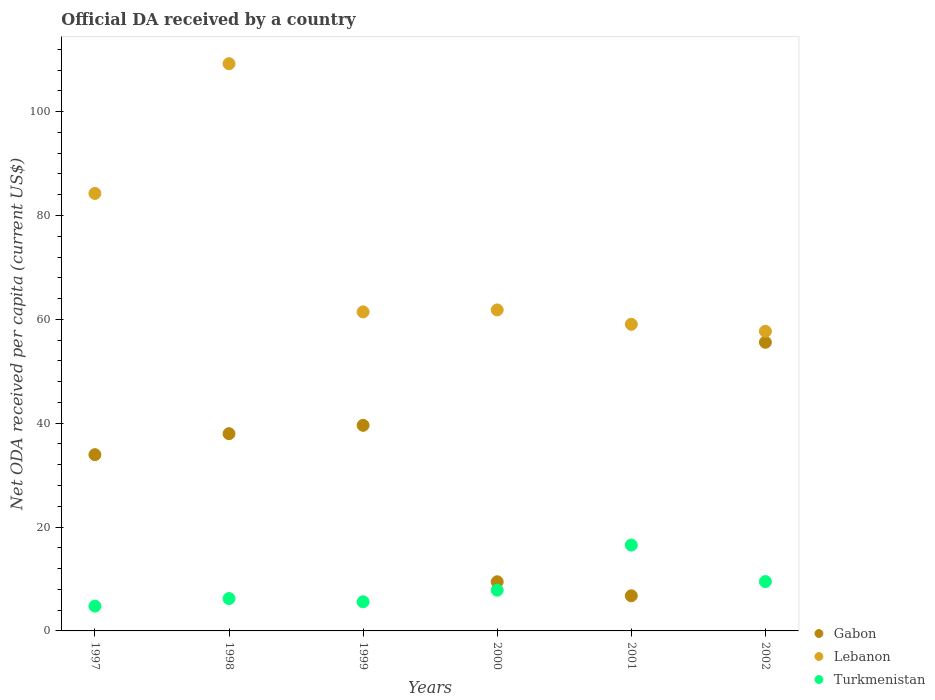Is the number of dotlines equal to the number of legend labels?
Provide a short and direct response. Yes. What is the ODA received in in Lebanon in 2000?
Offer a very short reply. 61.82. Across all years, what is the maximum ODA received in in Lebanon?
Your response must be concise. 109.24. Across all years, what is the minimum ODA received in in Gabon?
Your answer should be compact. 6.77. In which year was the ODA received in in Lebanon maximum?
Your answer should be compact. 1998. In which year was the ODA received in in Gabon minimum?
Give a very brief answer. 2001. What is the total ODA received in in Gabon in the graph?
Your answer should be very brief. 183.35. What is the difference between the ODA received in in Gabon in 1999 and that in 2001?
Provide a short and direct response. 32.83. What is the difference between the ODA received in in Lebanon in 1998 and the ODA received in in Turkmenistan in 1997?
Provide a succinct answer. 104.47. What is the average ODA received in in Turkmenistan per year?
Offer a terse response. 8.42. In the year 2000, what is the difference between the ODA received in in Gabon and ODA received in in Turkmenistan?
Offer a terse response. 1.63. In how many years, is the ODA received in in Lebanon greater than 52 US$?
Keep it short and to the point. 6. What is the ratio of the ODA received in in Lebanon in 2000 to that in 2001?
Your response must be concise. 1.05. Is the ODA received in in Lebanon in 1998 less than that in 2002?
Provide a short and direct response. No. Is the difference between the ODA received in in Gabon in 1998 and 2002 greater than the difference between the ODA received in in Turkmenistan in 1998 and 2002?
Your answer should be very brief. No. What is the difference between the highest and the second highest ODA received in in Gabon?
Offer a terse response. 15.99. What is the difference between the highest and the lowest ODA received in in Lebanon?
Your answer should be compact. 51.54. In how many years, is the ODA received in in Lebanon greater than the average ODA received in in Lebanon taken over all years?
Your answer should be compact. 2. How many years are there in the graph?
Provide a succinct answer. 6. What is the difference between two consecutive major ticks on the Y-axis?
Your response must be concise. 20. How many legend labels are there?
Offer a very short reply. 3. What is the title of the graph?
Ensure brevity in your answer.  Official DA received by a country. What is the label or title of the X-axis?
Provide a succinct answer. Years. What is the label or title of the Y-axis?
Your answer should be compact. Net ODA received per capita (current US$). What is the Net ODA received per capita (current US$) in Gabon in 1997?
Your response must be concise. 33.95. What is the Net ODA received per capita (current US$) of Lebanon in 1997?
Make the answer very short. 84.26. What is the Net ODA received per capita (current US$) of Turkmenistan in 1997?
Keep it short and to the point. 4.77. What is the Net ODA received per capita (current US$) in Gabon in 1998?
Your answer should be compact. 37.98. What is the Net ODA received per capita (current US$) in Lebanon in 1998?
Make the answer very short. 109.24. What is the Net ODA received per capita (current US$) in Turkmenistan in 1998?
Offer a terse response. 6.24. What is the Net ODA received per capita (current US$) of Gabon in 1999?
Your response must be concise. 39.6. What is the Net ODA received per capita (current US$) in Lebanon in 1999?
Provide a succinct answer. 61.44. What is the Net ODA received per capita (current US$) in Turkmenistan in 1999?
Provide a succinct answer. 5.61. What is the Net ODA received per capita (current US$) of Gabon in 2000?
Make the answer very short. 9.47. What is the Net ODA received per capita (current US$) in Lebanon in 2000?
Give a very brief answer. 61.82. What is the Net ODA received per capita (current US$) of Turkmenistan in 2000?
Ensure brevity in your answer.  7.84. What is the Net ODA received per capita (current US$) in Gabon in 2001?
Ensure brevity in your answer.  6.77. What is the Net ODA received per capita (current US$) in Lebanon in 2001?
Provide a succinct answer. 59.06. What is the Net ODA received per capita (current US$) in Turkmenistan in 2001?
Give a very brief answer. 16.53. What is the Net ODA received per capita (current US$) in Gabon in 2002?
Make the answer very short. 55.59. What is the Net ODA received per capita (current US$) in Lebanon in 2002?
Your response must be concise. 57.7. What is the Net ODA received per capita (current US$) in Turkmenistan in 2002?
Provide a short and direct response. 9.51. Across all years, what is the maximum Net ODA received per capita (current US$) of Gabon?
Ensure brevity in your answer.  55.59. Across all years, what is the maximum Net ODA received per capita (current US$) of Lebanon?
Ensure brevity in your answer.  109.24. Across all years, what is the maximum Net ODA received per capita (current US$) of Turkmenistan?
Your response must be concise. 16.53. Across all years, what is the minimum Net ODA received per capita (current US$) of Gabon?
Give a very brief answer. 6.77. Across all years, what is the minimum Net ODA received per capita (current US$) in Lebanon?
Provide a succinct answer. 57.7. Across all years, what is the minimum Net ODA received per capita (current US$) in Turkmenistan?
Your response must be concise. 4.77. What is the total Net ODA received per capita (current US$) in Gabon in the graph?
Offer a very short reply. 183.35. What is the total Net ODA received per capita (current US$) in Lebanon in the graph?
Offer a terse response. 433.52. What is the total Net ODA received per capita (current US$) in Turkmenistan in the graph?
Your response must be concise. 50.51. What is the difference between the Net ODA received per capita (current US$) in Gabon in 1997 and that in 1998?
Your answer should be compact. -4.04. What is the difference between the Net ODA received per capita (current US$) of Lebanon in 1997 and that in 1998?
Provide a succinct answer. -24.98. What is the difference between the Net ODA received per capita (current US$) in Turkmenistan in 1997 and that in 1998?
Ensure brevity in your answer.  -1.46. What is the difference between the Net ODA received per capita (current US$) in Gabon in 1997 and that in 1999?
Give a very brief answer. -5.65. What is the difference between the Net ODA received per capita (current US$) of Lebanon in 1997 and that in 1999?
Your answer should be compact. 22.82. What is the difference between the Net ODA received per capita (current US$) in Turkmenistan in 1997 and that in 1999?
Provide a succinct answer. -0.84. What is the difference between the Net ODA received per capita (current US$) of Gabon in 1997 and that in 2000?
Ensure brevity in your answer.  24.48. What is the difference between the Net ODA received per capita (current US$) of Lebanon in 1997 and that in 2000?
Your response must be concise. 22.44. What is the difference between the Net ODA received per capita (current US$) of Turkmenistan in 1997 and that in 2000?
Your answer should be compact. -3.07. What is the difference between the Net ODA received per capita (current US$) in Gabon in 1997 and that in 2001?
Offer a very short reply. 27.18. What is the difference between the Net ODA received per capita (current US$) in Lebanon in 1997 and that in 2001?
Make the answer very short. 25.2. What is the difference between the Net ODA received per capita (current US$) of Turkmenistan in 1997 and that in 2001?
Ensure brevity in your answer.  -11.76. What is the difference between the Net ODA received per capita (current US$) in Gabon in 1997 and that in 2002?
Your response must be concise. -21.64. What is the difference between the Net ODA received per capita (current US$) of Lebanon in 1997 and that in 2002?
Ensure brevity in your answer.  26.56. What is the difference between the Net ODA received per capita (current US$) of Turkmenistan in 1997 and that in 2002?
Offer a very short reply. -4.73. What is the difference between the Net ODA received per capita (current US$) of Gabon in 1998 and that in 1999?
Your answer should be compact. -1.61. What is the difference between the Net ODA received per capita (current US$) of Lebanon in 1998 and that in 1999?
Offer a terse response. 47.8. What is the difference between the Net ODA received per capita (current US$) of Turkmenistan in 1998 and that in 1999?
Offer a very short reply. 0.62. What is the difference between the Net ODA received per capita (current US$) of Gabon in 1998 and that in 2000?
Make the answer very short. 28.52. What is the difference between the Net ODA received per capita (current US$) of Lebanon in 1998 and that in 2000?
Ensure brevity in your answer.  47.42. What is the difference between the Net ODA received per capita (current US$) in Turkmenistan in 1998 and that in 2000?
Offer a terse response. -1.61. What is the difference between the Net ODA received per capita (current US$) in Gabon in 1998 and that in 2001?
Ensure brevity in your answer.  31.22. What is the difference between the Net ODA received per capita (current US$) in Lebanon in 1998 and that in 2001?
Offer a terse response. 50.19. What is the difference between the Net ODA received per capita (current US$) of Turkmenistan in 1998 and that in 2001?
Keep it short and to the point. -10.3. What is the difference between the Net ODA received per capita (current US$) of Gabon in 1998 and that in 2002?
Offer a very short reply. -17.6. What is the difference between the Net ODA received per capita (current US$) of Lebanon in 1998 and that in 2002?
Your response must be concise. 51.54. What is the difference between the Net ODA received per capita (current US$) of Turkmenistan in 1998 and that in 2002?
Your answer should be compact. -3.27. What is the difference between the Net ODA received per capita (current US$) in Gabon in 1999 and that in 2000?
Your answer should be compact. 30.13. What is the difference between the Net ODA received per capita (current US$) in Lebanon in 1999 and that in 2000?
Give a very brief answer. -0.38. What is the difference between the Net ODA received per capita (current US$) of Turkmenistan in 1999 and that in 2000?
Keep it short and to the point. -2.23. What is the difference between the Net ODA received per capita (current US$) of Gabon in 1999 and that in 2001?
Your response must be concise. 32.83. What is the difference between the Net ODA received per capita (current US$) in Lebanon in 1999 and that in 2001?
Your answer should be very brief. 2.39. What is the difference between the Net ODA received per capita (current US$) of Turkmenistan in 1999 and that in 2001?
Offer a very short reply. -10.92. What is the difference between the Net ODA received per capita (current US$) of Gabon in 1999 and that in 2002?
Give a very brief answer. -15.99. What is the difference between the Net ODA received per capita (current US$) of Lebanon in 1999 and that in 2002?
Provide a succinct answer. 3.74. What is the difference between the Net ODA received per capita (current US$) of Turkmenistan in 1999 and that in 2002?
Offer a very short reply. -3.89. What is the difference between the Net ODA received per capita (current US$) of Gabon in 2000 and that in 2001?
Ensure brevity in your answer.  2.7. What is the difference between the Net ODA received per capita (current US$) of Lebanon in 2000 and that in 2001?
Your answer should be compact. 2.76. What is the difference between the Net ODA received per capita (current US$) of Turkmenistan in 2000 and that in 2001?
Your answer should be compact. -8.69. What is the difference between the Net ODA received per capita (current US$) in Gabon in 2000 and that in 2002?
Ensure brevity in your answer.  -46.12. What is the difference between the Net ODA received per capita (current US$) in Lebanon in 2000 and that in 2002?
Provide a short and direct response. 4.12. What is the difference between the Net ODA received per capita (current US$) in Turkmenistan in 2000 and that in 2002?
Provide a short and direct response. -1.66. What is the difference between the Net ODA received per capita (current US$) of Gabon in 2001 and that in 2002?
Your answer should be compact. -48.82. What is the difference between the Net ODA received per capita (current US$) of Lebanon in 2001 and that in 2002?
Your answer should be very brief. 1.36. What is the difference between the Net ODA received per capita (current US$) of Turkmenistan in 2001 and that in 2002?
Offer a terse response. 7.03. What is the difference between the Net ODA received per capita (current US$) in Gabon in 1997 and the Net ODA received per capita (current US$) in Lebanon in 1998?
Give a very brief answer. -75.3. What is the difference between the Net ODA received per capita (current US$) of Gabon in 1997 and the Net ODA received per capita (current US$) of Turkmenistan in 1998?
Your answer should be very brief. 27.71. What is the difference between the Net ODA received per capita (current US$) of Lebanon in 1997 and the Net ODA received per capita (current US$) of Turkmenistan in 1998?
Provide a succinct answer. 78.02. What is the difference between the Net ODA received per capita (current US$) of Gabon in 1997 and the Net ODA received per capita (current US$) of Lebanon in 1999?
Provide a short and direct response. -27.5. What is the difference between the Net ODA received per capita (current US$) in Gabon in 1997 and the Net ODA received per capita (current US$) in Turkmenistan in 1999?
Offer a very short reply. 28.33. What is the difference between the Net ODA received per capita (current US$) in Lebanon in 1997 and the Net ODA received per capita (current US$) in Turkmenistan in 1999?
Keep it short and to the point. 78.65. What is the difference between the Net ODA received per capita (current US$) of Gabon in 1997 and the Net ODA received per capita (current US$) of Lebanon in 2000?
Your answer should be compact. -27.87. What is the difference between the Net ODA received per capita (current US$) in Gabon in 1997 and the Net ODA received per capita (current US$) in Turkmenistan in 2000?
Offer a terse response. 26.11. What is the difference between the Net ODA received per capita (current US$) of Lebanon in 1997 and the Net ODA received per capita (current US$) of Turkmenistan in 2000?
Provide a short and direct response. 76.42. What is the difference between the Net ODA received per capita (current US$) of Gabon in 1997 and the Net ODA received per capita (current US$) of Lebanon in 2001?
Your answer should be compact. -25.11. What is the difference between the Net ODA received per capita (current US$) of Gabon in 1997 and the Net ODA received per capita (current US$) of Turkmenistan in 2001?
Your answer should be compact. 17.41. What is the difference between the Net ODA received per capita (current US$) of Lebanon in 1997 and the Net ODA received per capita (current US$) of Turkmenistan in 2001?
Make the answer very short. 67.73. What is the difference between the Net ODA received per capita (current US$) of Gabon in 1997 and the Net ODA received per capita (current US$) of Lebanon in 2002?
Provide a succinct answer. -23.75. What is the difference between the Net ODA received per capita (current US$) of Gabon in 1997 and the Net ODA received per capita (current US$) of Turkmenistan in 2002?
Your response must be concise. 24.44. What is the difference between the Net ODA received per capita (current US$) of Lebanon in 1997 and the Net ODA received per capita (current US$) of Turkmenistan in 2002?
Keep it short and to the point. 74.75. What is the difference between the Net ODA received per capita (current US$) of Gabon in 1998 and the Net ODA received per capita (current US$) of Lebanon in 1999?
Provide a succinct answer. -23.46. What is the difference between the Net ODA received per capita (current US$) in Gabon in 1998 and the Net ODA received per capita (current US$) in Turkmenistan in 1999?
Offer a terse response. 32.37. What is the difference between the Net ODA received per capita (current US$) in Lebanon in 1998 and the Net ODA received per capita (current US$) in Turkmenistan in 1999?
Your response must be concise. 103.63. What is the difference between the Net ODA received per capita (current US$) of Gabon in 1998 and the Net ODA received per capita (current US$) of Lebanon in 2000?
Offer a very short reply. -23.84. What is the difference between the Net ODA received per capita (current US$) of Gabon in 1998 and the Net ODA received per capita (current US$) of Turkmenistan in 2000?
Provide a short and direct response. 30.14. What is the difference between the Net ODA received per capita (current US$) in Lebanon in 1998 and the Net ODA received per capita (current US$) in Turkmenistan in 2000?
Your answer should be very brief. 101.4. What is the difference between the Net ODA received per capita (current US$) of Gabon in 1998 and the Net ODA received per capita (current US$) of Lebanon in 2001?
Provide a succinct answer. -21.07. What is the difference between the Net ODA received per capita (current US$) of Gabon in 1998 and the Net ODA received per capita (current US$) of Turkmenistan in 2001?
Give a very brief answer. 21.45. What is the difference between the Net ODA received per capita (current US$) of Lebanon in 1998 and the Net ODA received per capita (current US$) of Turkmenistan in 2001?
Your response must be concise. 92.71. What is the difference between the Net ODA received per capita (current US$) in Gabon in 1998 and the Net ODA received per capita (current US$) in Lebanon in 2002?
Provide a short and direct response. -19.72. What is the difference between the Net ODA received per capita (current US$) of Gabon in 1998 and the Net ODA received per capita (current US$) of Turkmenistan in 2002?
Ensure brevity in your answer.  28.48. What is the difference between the Net ODA received per capita (current US$) in Lebanon in 1998 and the Net ODA received per capita (current US$) in Turkmenistan in 2002?
Offer a very short reply. 99.74. What is the difference between the Net ODA received per capita (current US$) of Gabon in 1999 and the Net ODA received per capita (current US$) of Lebanon in 2000?
Provide a succinct answer. -22.22. What is the difference between the Net ODA received per capita (current US$) in Gabon in 1999 and the Net ODA received per capita (current US$) in Turkmenistan in 2000?
Ensure brevity in your answer.  31.75. What is the difference between the Net ODA received per capita (current US$) of Lebanon in 1999 and the Net ODA received per capita (current US$) of Turkmenistan in 2000?
Provide a short and direct response. 53.6. What is the difference between the Net ODA received per capita (current US$) of Gabon in 1999 and the Net ODA received per capita (current US$) of Lebanon in 2001?
Your answer should be very brief. -19.46. What is the difference between the Net ODA received per capita (current US$) of Gabon in 1999 and the Net ODA received per capita (current US$) of Turkmenistan in 2001?
Provide a short and direct response. 23.06. What is the difference between the Net ODA received per capita (current US$) in Lebanon in 1999 and the Net ODA received per capita (current US$) in Turkmenistan in 2001?
Offer a terse response. 44.91. What is the difference between the Net ODA received per capita (current US$) of Gabon in 1999 and the Net ODA received per capita (current US$) of Lebanon in 2002?
Ensure brevity in your answer.  -18.11. What is the difference between the Net ODA received per capita (current US$) of Gabon in 1999 and the Net ODA received per capita (current US$) of Turkmenistan in 2002?
Offer a terse response. 30.09. What is the difference between the Net ODA received per capita (current US$) in Lebanon in 1999 and the Net ODA received per capita (current US$) in Turkmenistan in 2002?
Make the answer very short. 51.94. What is the difference between the Net ODA received per capita (current US$) in Gabon in 2000 and the Net ODA received per capita (current US$) in Lebanon in 2001?
Offer a terse response. -49.59. What is the difference between the Net ODA received per capita (current US$) of Gabon in 2000 and the Net ODA received per capita (current US$) of Turkmenistan in 2001?
Ensure brevity in your answer.  -7.07. What is the difference between the Net ODA received per capita (current US$) of Lebanon in 2000 and the Net ODA received per capita (current US$) of Turkmenistan in 2001?
Provide a short and direct response. 45.29. What is the difference between the Net ODA received per capita (current US$) of Gabon in 2000 and the Net ODA received per capita (current US$) of Lebanon in 2002?
Provide a short and direct response. -48.23. What is the difference between the Net ODA received per capita (current US$) in Gabon in 2000 and the Net ODA received per capita (current US$) in Turkmenistan in 2002?
Offer a very short reply. -0.04. What is the difference between the Net ODA received per capita (current US$) in Lebanon in 2000 and the Net ODA received per capita (current US$) in Turkmenistan in 2002?
Your answer should be compact. 52.31. What is the difference between the Net ODA received per capita (current US$) of Gabon in 2001 and the Net ODA received per capita (current US$) of Lebanon in 2002?
Keep it short and to the point. -50.93. What is the difference between the Net ODA received per capita (current US$) in Gabon in 2001 and the Net ODA received per capita (current US$) in Turkmenistan in 2002?
Your answer should be very brief. -2.74. What is the difference between the Net ODA received per capita (current US$) of Lebanon in 2001 and the Net ODA received per capita (current US$) of Turkmenistan in 2002?
Ensure brevity in your answer.  49.55. What is the average Net ODA received per capita (current US$) in Gabon per year?
Offer a terse response. 30.56. What is the average Net ODA received per capita (current US$) in Lebanon per year?
Offer a terse response. 72.25. What is the average Net ODA received per capita (current US$) of Turkmenistan per year?
Provide a succinct answer. 8.42. In the year 1997, what is the difference between the Net ODA received per capita (current US$) in Gabon and Net ODA received per capita (current US$) in Lebanon?
Your answer should be very brief. -50.31. In the year 1997, what is the difference between the Net ODA received per capita (current US$) of Gabon and Net ODA received per capita (current US$) of Turkmenistan?
Provide a short and direct response. 29.17. In the year 1997, what is the difference between the Net ODA received per capita (current US$) of Lebanon and Net ODA received per capita (current US$) of Turkmenistan?
Ensure brevity in your answer.  79.49. In the year 1998, what is the difference between the Net ODA received per capita (current US$) in Gabon and Net ODA received per capita (current US$) in Lebanon?
Your answer should be very brief. -71.26. In the year 1998, what is the difference between the Net ODA received per capita (current US$) in Gabon and Net ODA received per capita (current US$) in Turkmenistan?
Your answer should be very brief. 31.75. In the year 1998, what is the difference between the Net ODA received per capita (current US$) in Lebanon and Net ODA received per capita (current US$) in Turkmenistan?
Ensure brevity in your answer.  103.01. In the year 1999, what is the difference between the Net ODA received per capita (current US$) in Gabon and Net ODA received per capita (current US$) in Lebanon?
Keep it short and to the point. -21.85. In the year 1999, what is the difference between the Net ODA received per capita (current US$) in Gabon and Net ODA received per capita (current US$) in Turkmenistan?
Offer a very short reply. 33.98. In the year 1999, what is the difference between the Net ODA received per capita (current US$) in Lebanon and Net ODA received per capita (current US$) in Turkmenistan?
Your response must be concise. 55.83. In the year 2000, what is the difference between the Net ODA received per capita (current US$) in Gabon and Net ODA received per capita (current US$) in Lebanon?
Provide a succinct answer. -52.35. In the year 2000, what is the difference between the Net ODA received per capita (current US$) in Gabon and Net ODA received per capita (current US$) in Turkmenistan?
Keep it short and to the point. 1.63. In the year 2000, what is the difference between the Net ODA received per capita (current US$) in Lebanon and Net ODA received per capita (current US$) in Turkmenistan?
Ensure brevity in your answer.  53.98. In the year 2001, what is the difference between the Net ODA received per capita (current US$) in Gabon and Net ODA received per capita (current US$) in Lebanon?
Give a very brief answer. -52.29. In the year 2001, what is the difference between the Net ODA received per capita (current US$) in Gabon and Net ODA received per capita (current US$) in Turkmenistan?
Make the answer very short. -9.77. In the year 2001, what is the difference between the Net ODA received per capita (current US$) in Lebanon and Net ODA received per capita (current US$) in Turkmenistan?
Your answer should be very brief. 42.52. In the year 2002, what is the difference between the Net ODA received per capita (current US$) of Gabon and Net ODA received per capita (current US$) of Lebanon?
Provide a short and direct response. -2.12. In the year 2002, what is the difference between the Net ODA received per capita (current US$) in Gabon and Net ODA received per capita (current US$) in Turkmenistan?
Give a very brief answer. 46.08. In the year 2002, what is the difference between the Net ODA received per capita (current US$) of Lebanon and Net ODA received per capita (current US$) of Turkmenistan?
Your response must be concise. 48.19. What is the ratio of the Net ODA received per capita (current US$) in Gabon in 1997 to that in 1998?
Provide a succinct answer. 0.89. What is the ratio of the Net ODA received per capita (current US$) of Lebanon in 1997 to that in 1998?
Give a very brief answer. 0.77. What is the ratio of the Net ODA received per capita (current US$) in Turkmenistan in 1997 to that in 1998?
Your response must be concise. 0.77. What is the ratio of the Net ODA received per capita (current US$) of Gabon in 1997 to that in 1999?
Give a very brief answer. 0.86. What is the ratio of the Net ODA received per capita (current US$) of Lebanon in 1997 to that in 1999?
Offer a very short reply. 1.37. What is the ratio of the Net ODA received per capita (current US$) in Turkmenistan in 1997 to that in 1999?
Give a very brief answer. 0.85. What is the ratio of the Net ODA received per capita (current US$) in Gabon in 1997 to that in 2000?
Offer a very short reply. 3.59. What is the ratio of the Net ODA received per capita (current US$) in Lebanon in 1997 to that in 2000?
Make the answer very short. 1.36. What is the ratio of the Net ODA received per capita (current US$) of Turkmenistan in 1997 to that in 2000?
Keep it short and to the point. 0.61. What is the ratio of the Net ODA received per capita (current US$) in Gabon in 1997 to that in 2001?
Give a very brief answer. 5.02. What is the ratio of the Net ODA received per capita (current US$) of Lebanon in 1997 to that in 2001?
Keep it short and to the point. 1.43. What is the ratio of the Net ODA received per capita (current US$) in Turkmenistan in 1997 to that in 2001?
Make the answer very short. 0.29. What is the ratio of the Net ODA received per capita (current US$) in Gabon in 1997 to that in 2002?
Offer a terse response. 0.61. What is the ratio of the Net ODA received per capita (current US$) in Lebanon in 1997 to that in 2002?
Your response must be concise. 1.46. What is the ratio of the Net ODA received per capita (current US$) in Turkmenistan in 1997 to that in 2002?
Make the answer very short. 0.5. What is the ratio of the Net ODA received per capita (current US$) in Gabon in 1998 to that in 1999?
Keep it short and to the point. 0.96. What is the ratio of the Net ODA received per capita (current US$) in Lebanon in 1998 to that in 1999?
Your response must be concise. 1.78. What is the ratio of the Net ODA received per capita (current US$) in Turkmenistan in 1998 to that in 1999?
Provide a short and direct response. 1.11. What is the ratio of the Net ODA received per capita (current US$) in Gabon in 1998 to that in 2000?
Your answer should be compact. 4.01. What is the ratio of the Net ODA received per capita (current US$) in Lebanon in 1998 to that in 2000?
Your response must be concise. 1.77. What is the ratio of the Net ODA received per capita (current US$) in Turkmenistan in 1998 to that in 2000?
Make the answer very short. 0.8. What is the ratio of the Net ODA received per capita (current US$) in Gabon in 1998 to that in 2001?
Offer a terse response. 5.61. What is the ratio of the Net ODA received per capita (current US$) of Lebanon in 1998 to that in 2001?
Make the answer very short. 1.85. What is the ratio of the Net ODA received per capita (current US$) of Turkmenistan in 1998 to that in 2001?
Offer a very short reply. 0.38. What is the ratio of the Net ODA received per capita (current US$) of Gabon in 1998 to that in 2002?
Make the answer very short. 0.68. What is the ratio of the Net ODA received per capita (current US$) in Lebanon in 1998 to that in 2002?
Ensure brevity in your answer.  1.89. What is the ratio of the Net ODA received per capita (current US$) of Turkmenistan in 1998 to that in 2002?
Your answer should be compact. 0.66. What is the ratio of the Net ODA received per capita (current US$) of Gabon in 1999 to that in 2000?
Keep it short and to the point. 4.18. What is the ratio of the Net ODA received per capita (current US$) in Turkmenistan in 1999 to that in 2000?
Your answer should be very brief. 0.72. What is the ratio of the Net ODA received per capita (current US$) in Gabon in 1999 to that in 2001?
Make the answer very short. 5.85. What is the ratio of the Net ODA received per capita (current US$) of Lebanon in 1999 to that in 2001?
Provide a succinct answer. 1.04. What is the ratio of the Net ODA received per capita (current US$) of Turkmenistan in 1999 to that in 2001?
Ensure brevity in your answer.  0.34. What is the ratio of the Net ODA received per capita (current US$) of Gabon in 1999 to that in 2002?
Keep it short and to the point. 0.71. What is the ratio of the Net ODA received per capita (current US$) in Lebanon in 1999 to that in 2002?
Your answer should be compact. 1.06. What is the ratio of the Net ODA received per capita (current US$) in Turkmenistan in 1999 to that in 2002?
Offer a terse response. 0.59. What is the ratio of the Net ODA received per capita (current US$) in Gabon in 2000 to that in 2001?
Keep it short and to the point. 1.4. What is the ratio of the Net ODA received per capita (current US$) of Lebanon in 2000 to that in 2001?
Make the answer very short. 1.05. What is the ratio of the Net ODA received per capita (current US$) of Turkmenistan in 2000 to that in 2001?
Your answer should be very brief. 0.47. What is the ratio of the Net ODA received per capita (current US$) in Gabon in 2000 to that in 2002?
Keep it short and to the point. 0.17. What is the ratio of the Net ODA received per capita (current US$) of Lebanon in 2000 to that in 2002?
Your answer should be very brief. 1.07. What is the ratio of the Net ODA received per capita (current US$) in Turkmenistan in 2000 to that in 2002?
Make the answer very short. 0.82. What is the ratio of the Net ODA received per capita (current US$) in Gabon in 2001 to that in 2002?
Provide a short and direct response. 0.12. What is the ratio of the Net ODA received per capita (current US$) of Lebanon in 2001 to that in 2002?
Offer a terse response. 1.02. What is the ratio of the Net ODA received per capita (current US$) of Turkmenistan in 2001 to that in 2002?
Provide a short and direct response. 1.74. What is the difference between the highest and the second highest Net ODA received per capita (current US$) in Gabon?
Keep it short and to the point. 15.99. What is the difference between the highest and the second highest Net ODA received per capita (current US$) in Lebanon?
Offer a very short reply. 24.98. What is the difference between the highest and the second highest Net ODA received per capita (current US$) of Turkmenistan?
Your answer should be very brief. 7.03. What is the difference between the highest and the lowest Net ODA received per capita (current US$) of Gabon?
Keep it short and to the point. 48.82. What is the difference between the highest and the lowest Net ODA received per capita (current US$) in Lebanon?
Give a very brief answer. 51.54. What is the difference between the highest and the lowest Net ODA received per capita (current US$) of Turkmenistan?
Provide a short and direct response. 11.76. 